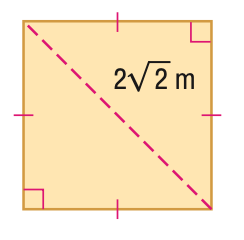Answer the mathemtical geometry problem and directly provide the correct option letter.
Question: Find the area of the figure. Round to the nearest hundredth, if necessary.
Choices: A: 4 B: 8 C: 16 D: 32 A 